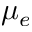<formula> <loc_0><loc_0><loc_500><loc_500>\mu _ { e }</formula> 